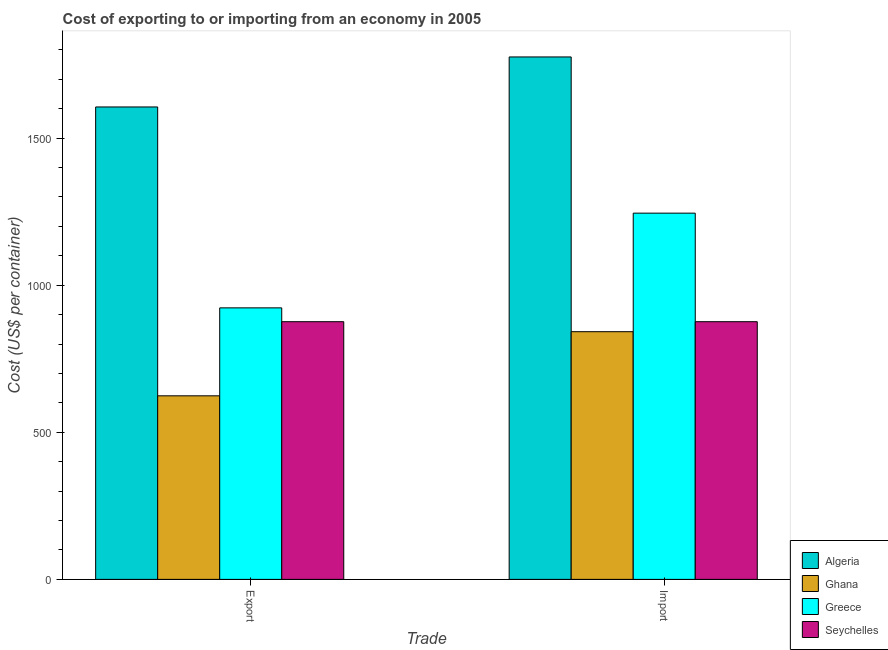How many different coloured bars are there?
Make the answer very short. 4. How many groups of bars are there?
Make the answer very short. 2. Are the number of bars per tick equal to the number of legend labels?
Offer a very short reply. Yes. How many bars are there on the 2nd tick from the right?
Your response must be concise. 4. What is the label of the 1st group of bars from the left?
Your answer should be compact. Export. What is the export cost in Seychelles?
Your answer should be compact. 876. Across all countries, what is the maximum export cost?
Your response must be concise. 1606. Across all countries, what is the minimum export cost?
Give a very brief answer. 624. In which country was the import cost maximum?
Offer a very short reply. Algeria. What is the total export cost in the graph?
Your answer should be very brief. 4029. What is the difference between the import cost in Ghana and that in Algeria?
Provide a succinct answer. -934. What is the difference between the export cost in Ghana and the import cost in Greece?
Make the answer very short. -621. What is the average export cost per country?
Provide a succinct answer. 1007.25. What is the difference between the import cost and export cost in Ghana?
Give a very brief answer. 218. In how many countries, is the export cost greater than 800 US$?
Ensure brevity in your answer.  3. What is the ratio of the import cost in Greece to that in Seychelles?
Offer a terse response. 1.42. Is the import cost in Greece less than that in Algeria?
Offer a terse response. Yes. In how many countries, is the export cost greater than the average export cost taken over all countries?
Offer a terse response. 1. What does the 4th bar from the left in Import represents?
Offer a very short reply. Seychelles. What does the 1st bar from the right in Import represents?
Ensure brevity in your answer.  Seychelles. How many countries are there in the graph?
Ensure brevity in your answer.  4. What is the difference between two consecutive major ticks on the Y-axis?
Provide a succinct answer. 500. Does the graph contain grids?
Keep it short and to the point. No. Where does the legend appear in the graph?
Your response must be concise. Bottom right. How many legend labels are there?
Keep it short and to the point. 4. What is the title of the graph?
Offer a very short reply. Cost of exporting to or importing from an economy in 2005. Does "Ethiopia" appear as one of the legend labels in the graph?
Provide a short and direct response. No. What is the label or title of the X-axis?
Provide a succinct answer. Trade. What is the label or title of the Y-axis?
Make the answer very short. Cost (US$ per container). What is the Cost (US$ per container) in Algeria in Export?
Your response must be concise. 1606. What is the Cost (US$ per container) of Ghana in Export?
Provide a short and direct response. 624. What is the Cost (US$ per container) in Greece in Export?
Keep it short and to the point. 923. What is the Cost (US$ per container) of Seychelles in Export?
Your answer should be very brief. 876. What is the Cost (US$ per container) of Algeria in Import?
Make the answer very short. 1776. What is the Cost (US$ per container) of Ghana in Import?
Offer a terse response. 842. What is the Cost (US$ per container) in Greece in Import?
Keep it short and to the point. 1245. What is the Cost (US$ per container) of Seychelles in Import?
Provide a short and direct response. 876. Across all Trade, what is the maximum Cost (US$ per container) of Algeria?
Provide a succinct answer. 1776. Across all Trade, what is the maximum Cost (US$ per container) of Ghana?
Your answer should be very brief. 842. Across all Trade, what is the maximum Cost (US$ per container) in Greece?
Keep it short and to the point. 1245. Across all Trade, what is the maximum Cost (US$ per container) in Seychelles?
Provide a short and direct response. 876. Across all Trade, what is the minimum Cost (US$ per container) of Algeria?
Your answer should be very brief. 1606. Across all Trade, what is the minimum Cost (US$ per container) of Ghana?
Provide a short and direct response. 624. Across all Trade, what is the minimum Cost (US$ per container) of Greece?
Make the answer very short. 923. Across all Trade, what is the minimum Cost (US$ per container) in Seychelles?
Give a very brief answer. 876. What is the total Cost (US$ per container) in Algeria in the graph?
Give a very brief answer. 3382. What is the total Cost (US$ per container) in Ghana in the graph?
Give a very brief answer. 1466. What is the total Cost (US$ per container) of Greece in the graph?
Offer a terse response. 2168. What is the total Cost (US$ per container) in Seychelles in the graph?
Give a very brief answer. 1752. What is the difference between the Cost (US$ per container) of Algeria in Export and that in Import?
Ensure brevity in your answer.  -170. What is the difference between the Cost (US$ per container) in Ghana in Export and that in Import?
Offer a very short reply. -218. What is the difference between the Cost (US$ per container) of Greece in Export and that in Import?
Your response must be concise. -322. What is the difference between the Cost (US$ per container) of Seychelles in Export and that in Import?
Offer a very short reply. 0. What is the difference between the Cost (US$ per container) in Algeria in Export and the Cost (US$ per container) in Ghana in Import?
Provide a short and direct response. 764. What is the difference between the Cost (US$ per container) of Algeria in Export and the Cost (US$ per container) of Greece in Import?
Provide a succinct answer. 361. What is the difference between the Cost (US$ per container) of Algeria in Export and the Cost (US$ per container) of Seychelles in Import?
Ensure brevity in your answer.  730. What is the difference between the Cost (US$ per container) of Ghana in Export and the Cost (US$ per container) of Greece in Import?
Keep it short and to the point. -621. What is the difference between the Cost (US$ per container) in Ghana in Export and the Cost (US$ per container) in Seychelles in Import?
Offer a terse response. -252. What is the difference between the Cost (US$ per container) of Greece in Export and the Cost (US$ per container) of Seychelles in Import?
Provide a succinct answer. 47. What is the average Cost (US$ per container) in Algeria per Trade?
Offer a terse response. 1691. What is the average Cost (US$ per container) in Ghana per Trade?
Ensure brevity in your answer.  733. What is the average Cost (US$ per container) in Greece per Trade?
Give a very brief answer. 1084. What is the average Cost (US$ per container) of Seychelles per Trade?
Make the answer very short. 876. What is the difference between the Cost (US$ per container) in Algeria and Cost (US$ per container) in Ghana in Export?
Ensure brevity in your answer.  982. What is the difference between the Cost (US$ per container) of Algeria and Cost (US$ per container) of Greece in Export?
Offer a very short reply. 683. What is the difference between the Cost (US$ per container) of Algeria and Cost (US$ per container) of Seychelles in Export?
Ensure brevity in your answer.  730. What is the difference between the Cost (US$ per container) in Ghana and Cost (US$ per container) in Greece in Export?
Make the answer very short. -299. What is the difference between the Cost (US$ per container) of Ghana and Cost (US$ per container) of Seychelles in Export?
Your answer should be compact. -252. What is the difference between the Cost (US$ per container) in Algeria and Cost (US$ per container) in Ghana in Import?
Offer a terse response. 934. What is the difference between the Cost (US$ per container) of Algeria and Cost (US$ per container) of Greece in Import?
Keep it short and to the point. 531. What is the difference between the Cost (US$ per container) of Algeria and Cost (US$ per container) of Seychelles in Import?
Keep it short and to the point. 900. What is the difference between the Cost (US$ per container) of Ghana and Cost (US$ per container) of Greece in Import?
Your answer should be compact. -403. What is the difference between the Cost (US$ per container) of Ghana and Cost (US$ per container) of Seychelles in Import?
Offer a terse response. -34. What is the difference between the Cost (US$ per container) of Greece and Cost (US$ per container) of Seychelles in Import?
Offer a very short reply. 369. What is the ratio of the Cost (US$ per container) of Algeria in Export to that in Import?
Give a very brief answer. 0.9. What is the ratio of the Cost (US$ per container) of Ghana in Export to that in Import?
Your answer should be very brief. 0.74. What is the ratio of the Cost (US$ per container) of Greece in Export to that in Import?
Your response must be concise. 0.74. What is the ratio of the Cost (US$ per container) of Seychelles in Export to that in Import?
Make the answer very short. 1. What is the difference between the highest and the second highest Cost (US$ per container) in Algeria?
Your response must be concise. 170. What is the difference between the highest and the second highest Cost (US$ per container) of Ghana?
Ensure brevity in your answer.  218. What is the difference between the highest and the second highest Cost (US$ per container) in Greece?
Give a very brief answer. 322. What is the difference between the highest and the second highest Cost (US$ per container) in Seychelles?
Your response must be concise. 0. What is the difference between the highest and the lowest Cost (US$ per container) of Algeria?
Ensure brevity in your answer.  170. What is the difference between the highest and the lowest Cost (US$ per container) of Ghana?
Offer a terse response. 218. What is the difference between the highest and the lowest Cost (US$ per container) in Greece?
Give a very brief answer. 322. What is the difference between the highest and the lowest Cost (US$ per container) of Seychelles?
Your answer should be compact. 0. 